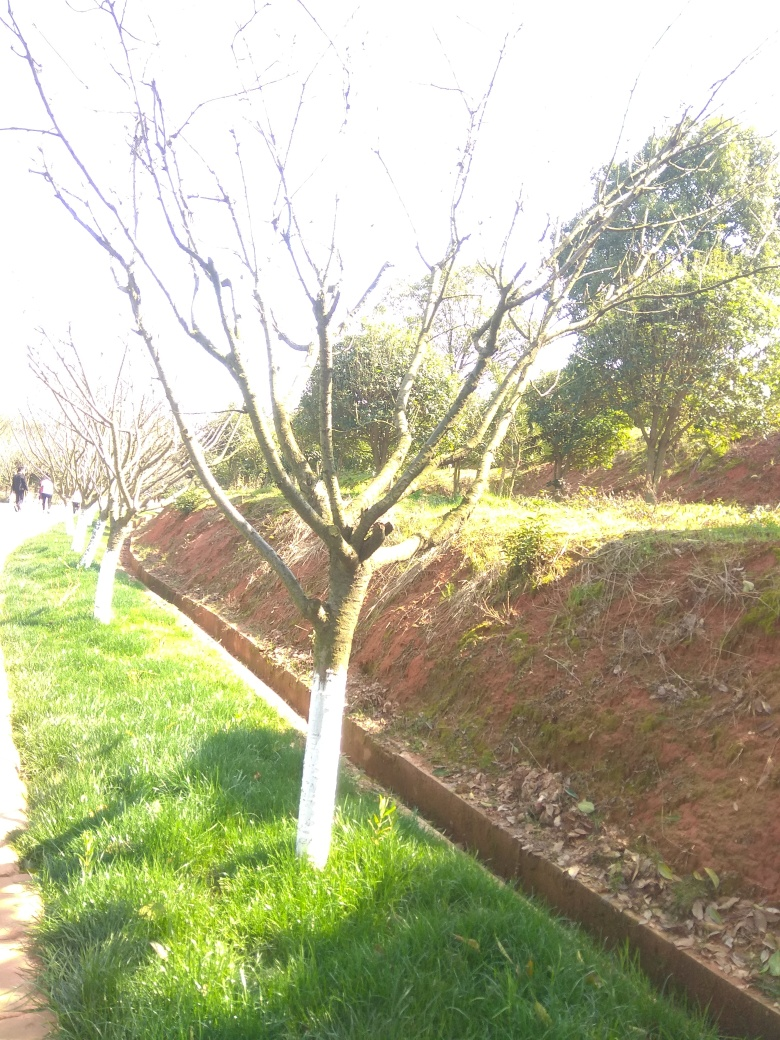What time of day does this photo seem to be taken, and how does that affect the photo? The long shadows and the bright quality of the light suggest that the photo was likely taken during the early afternoon. This can often lead to harsh shadows and an overexposure of lit areas, as we see here. Capturing photos during the 'golden hours' of early morning or late afternoon could result in a softer and more evenly distributed light. 